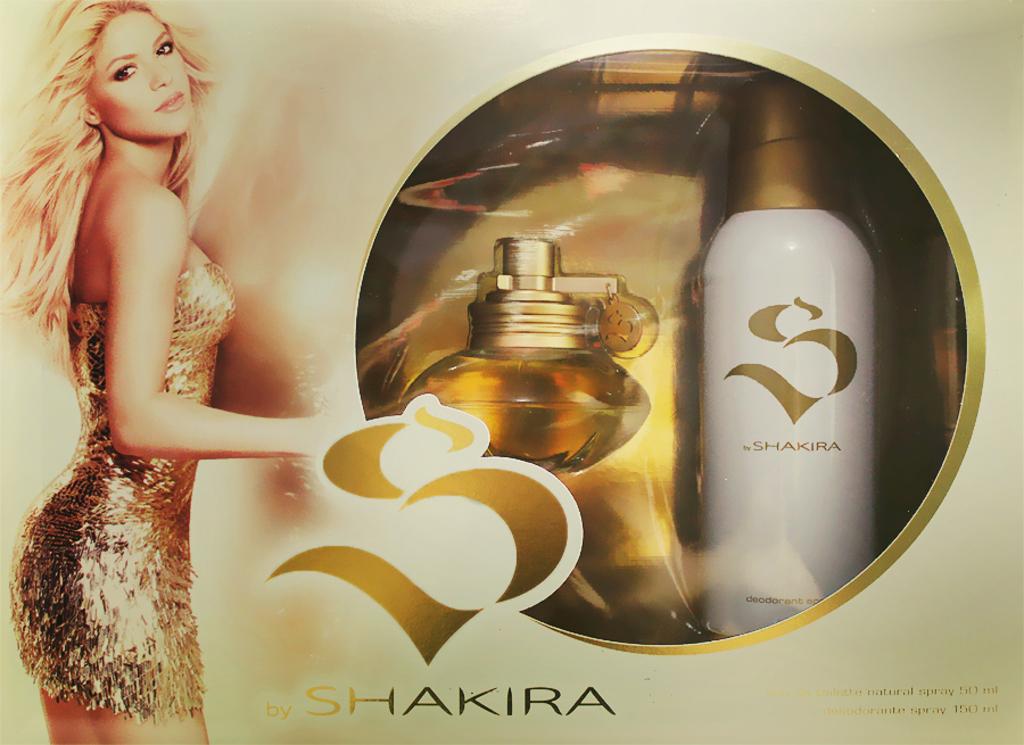Does the bottle have 150 ml?
Your response must be concise. Yes. 